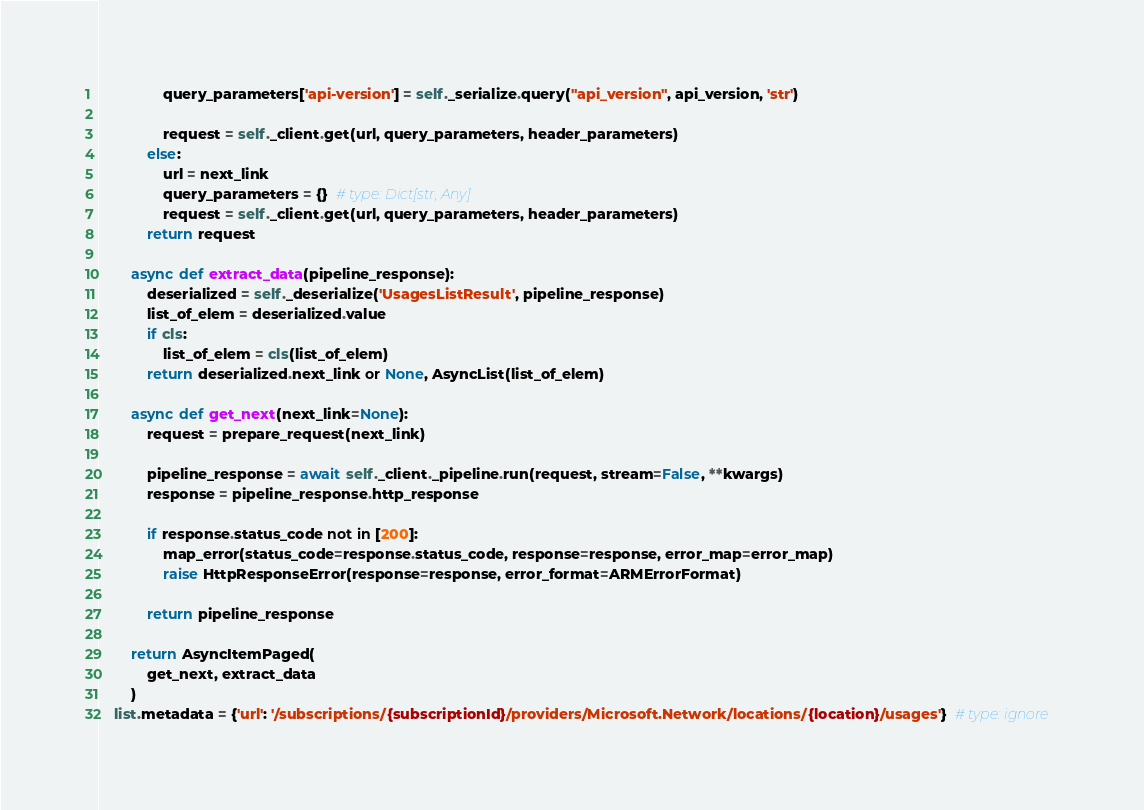<code> <loc_0><loc_0><loc_500><loc_500><_Python_>                query_parameters['api-version'] = self._serialize.query("api_version", api_version, 'str')

                request = self._client.get(url, query_parameters, header_parameters)
            else:
                url = next_link
                query_parameters = {}  # type: Dict[str, Any]
                request = self._client.get(url, query_parameters, header_parameters)
            return request

        async def extract_data(pipeline_response):
            deserialized = self._deserialize('UsagesListResult', pipeline_response)
            list_of_elem = deserialized.value
            if cls:
                list_of_elem = cls(list_of_elem)
            return deserialized.next_link or None, AsyncList(list_of_elem)

        async def get_next(next_link=None):
            request = prepare_request(next_link)

            pipeline_response = await self._client._pipeline.run(request, stream=False, **kwargs)
            response = pipeline_response.http_response

            if response.status_code not in [200]:
                map_error(status_code=response.status_code, response=response, error_map=error_map)
                raise HttpResponseError(response=response, error_format=ARMErrorFormat)

            return pipeline_response

        return AsyncItemPaged(
            get_next, extract_data
        )
    list.metadata = {'url': '/subscriptions/{subscriptionId}/providers/Microsoft.Network/locations/{location}/usages'}  # type: ignore
</code> 